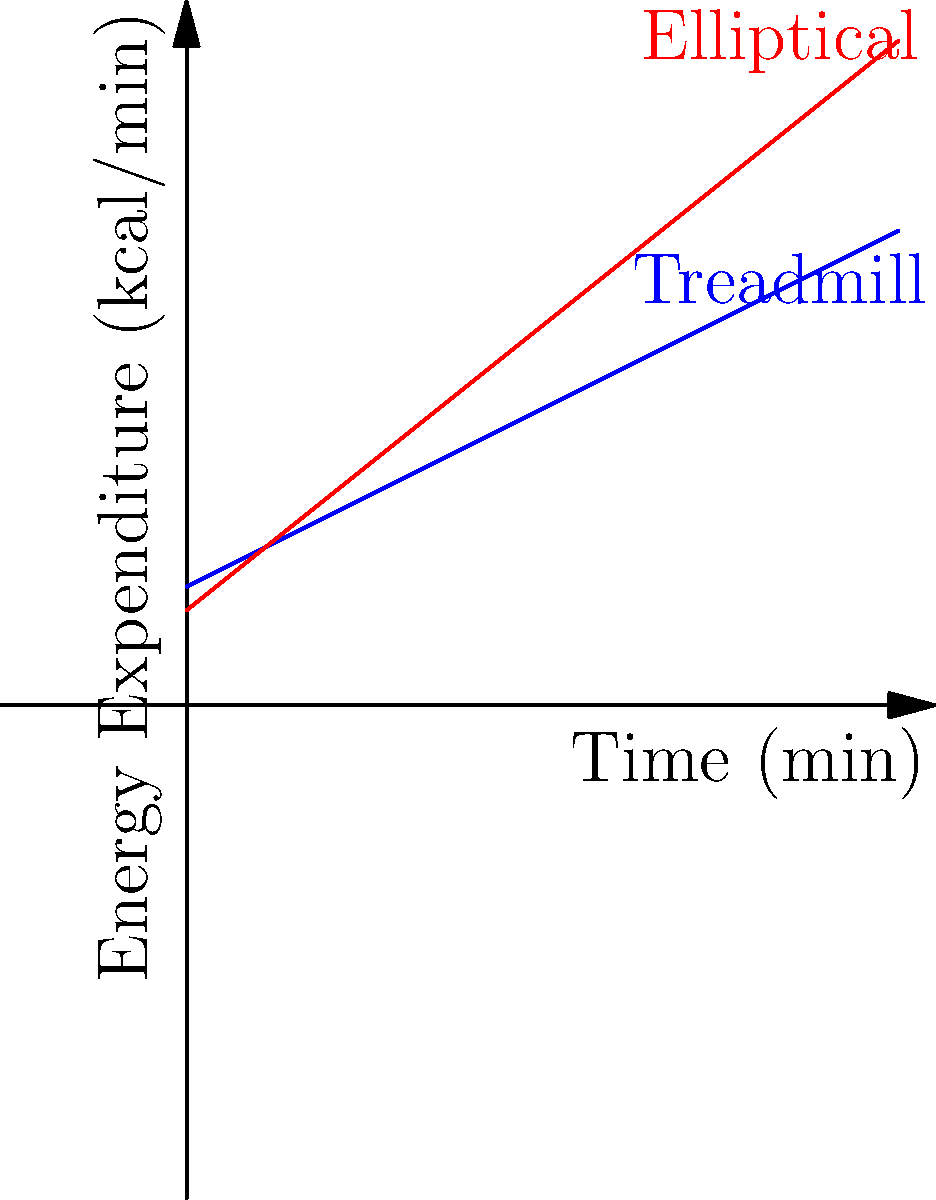As a solo traveler who appreciates attention to detail, you decide to analyze your energy expenditure during two different hotel gym workouts. The graph shows energy expenditure over time for treadmill and elliptical exercises. If you spend 20 minutes on each machine, what is the difference in total energy expenditure between the two workouts? Let's approach this step-by-step:

1. The energy expenditure for each machine is represented by a linear function:
   - Treadmill: $E_t(t) = 5 + 0.5t$
   - Elliptical: $E_e(t) = 4 + 0.8t$

2. To find the total energy expenditure, we need to calculate the area under each curve for 20 minutes:

3. For the treadmill:
   $\int_0^{20} (5 + 0.5t) dt = 5t + 0.25t^2 |_0^{20} = (100 + 100) - (0 + 0) = 200$ kcal

4. For the elliptical:
   $\int_0^{20} (4 + 0.8t) dt = 4t + 0.4t^2 |_0^{20} = (80 + 160) - (0 + 0) = 240$ kcal

5. The difference in total energy expenditure:
   $240 - 200 = 40$ kcal

Therefore, the elliptical workout expends 40 kcal more than the treadmill workout over 20 minutes.
Answer: 40 kcal 